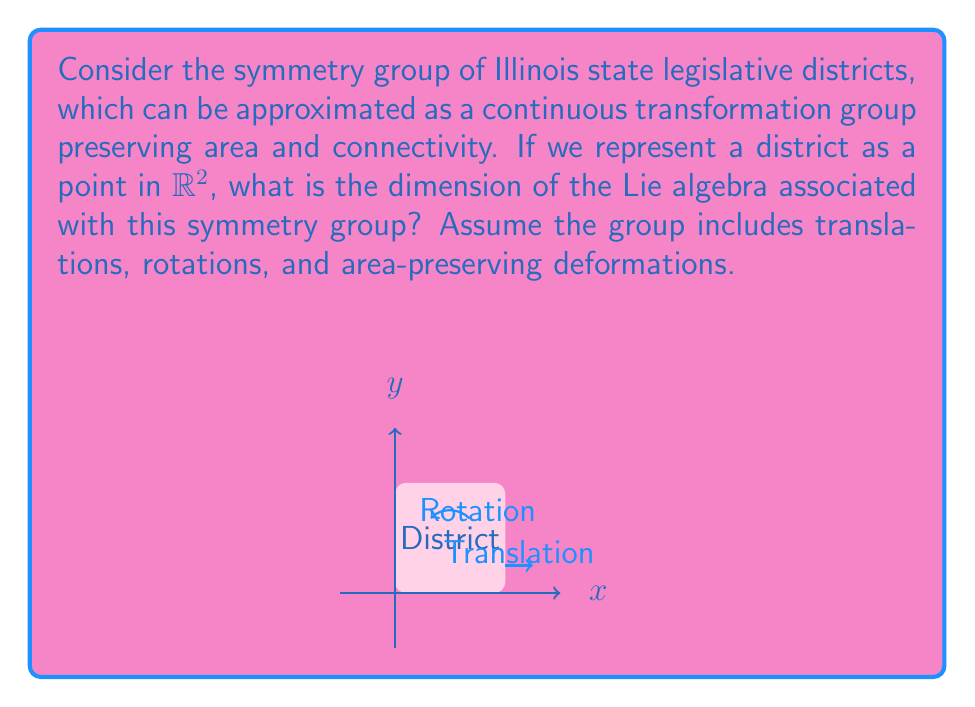Could you help me with this problem? To determine the dimension of the Lie algebra, we need to identify the generators of the symmetry group:

1. Translations: 
   - In the x-direction: $T_x = \frac{\partial}{\partial x}$
   - In the y-direction: $T_y = \frac{\partial}{\partial y}$

2. Rotations:
   - Around the origin: $R = x\frac{\partial}{\partial y} - y\frac{\partial}{\partial x}$

3. Area-preserving deformations:
   - These are generated by the divergence-free vector fields
   - A basis for these is given by: $D = x\frac{\partial}{\partial y} + y\frac{\partial}{\partial x}$

The Lie algebra is spanned by these generators: $\{T_x, T_y, R, D\}$

To confirm these are linearly independent:
$$\begin{vmatrix}
1 & 0 & -y & y \\
0 & 1 & x & x \\
0 & 0 & 0 & 0 \\
0 & 0 & 0 & 0
\end{vmatrix} \neq 0$$

Therefore, the dimension of the Lie algebra is equal to the number of linearly independent generators.
Answer: 4 